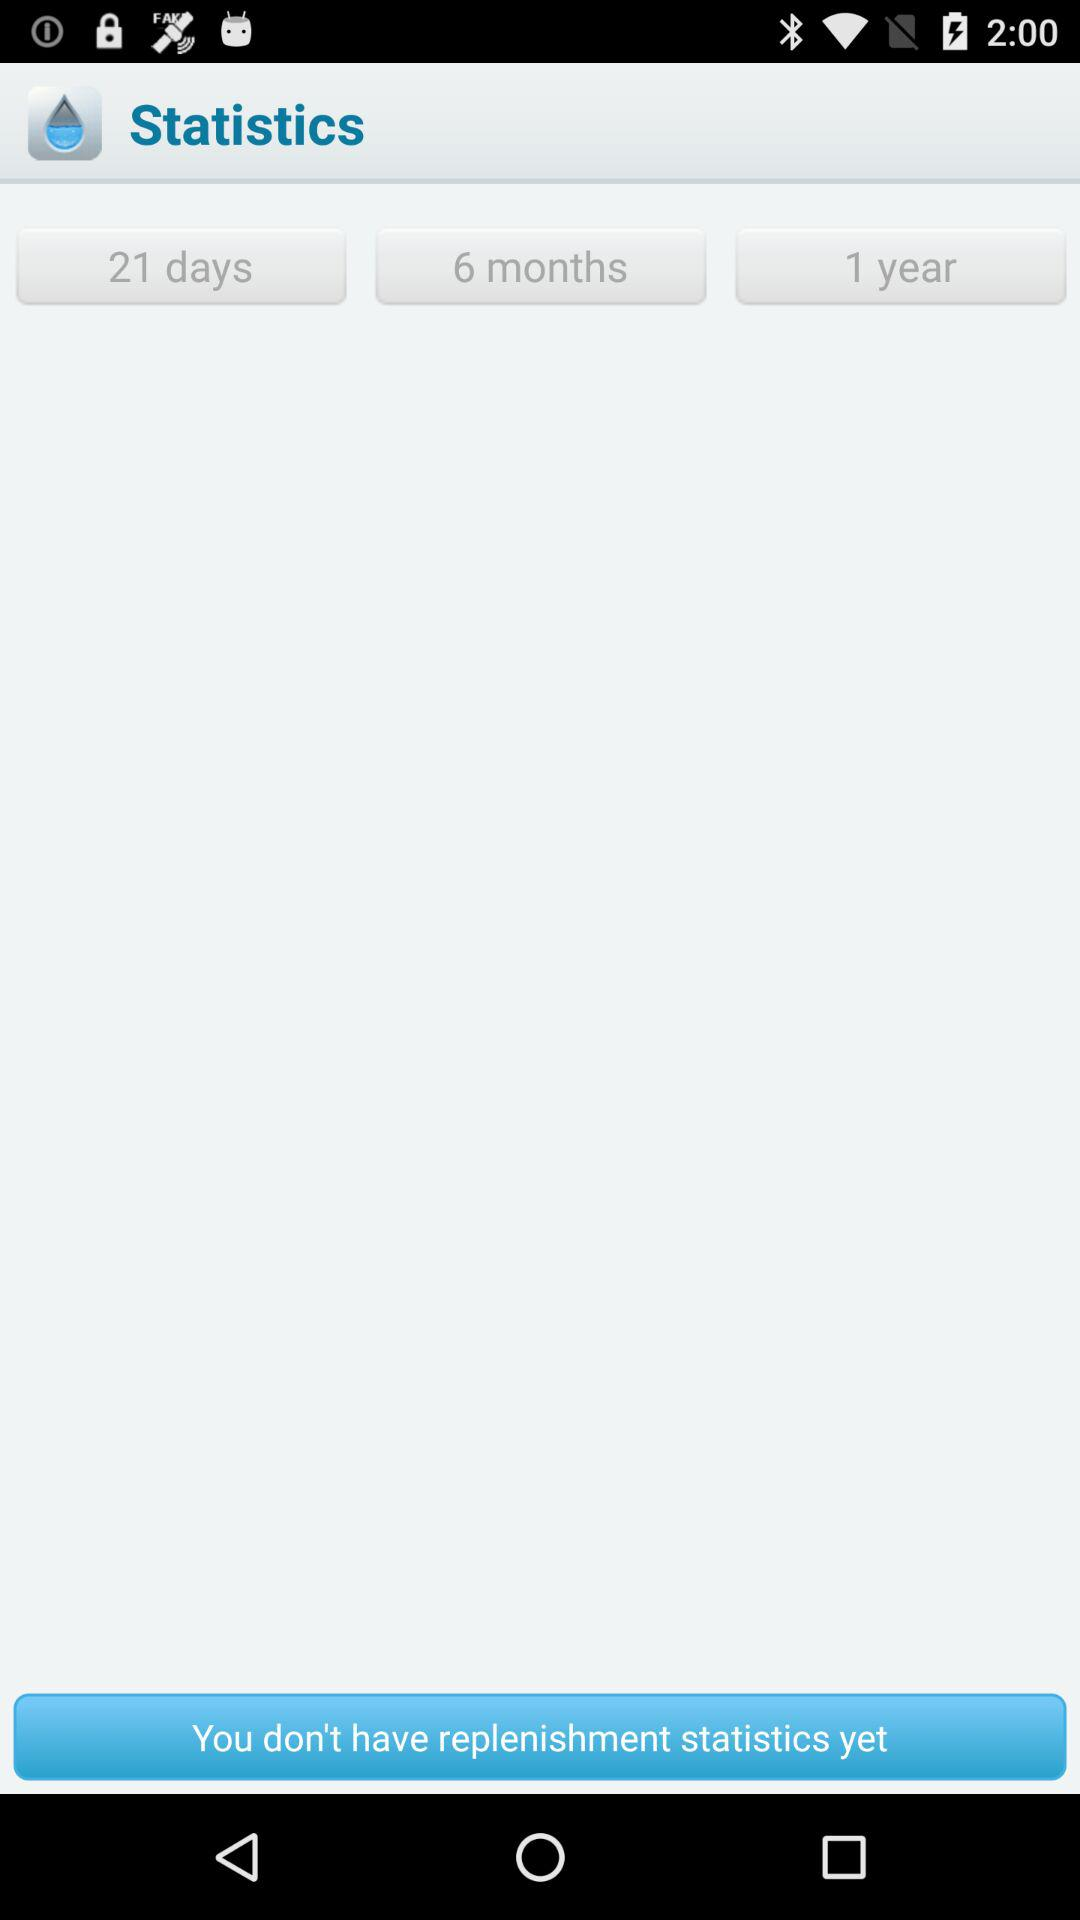Who is "Statistics" powered by?
When the provided information is insufficient, respond with <no answer>. <no answer> 